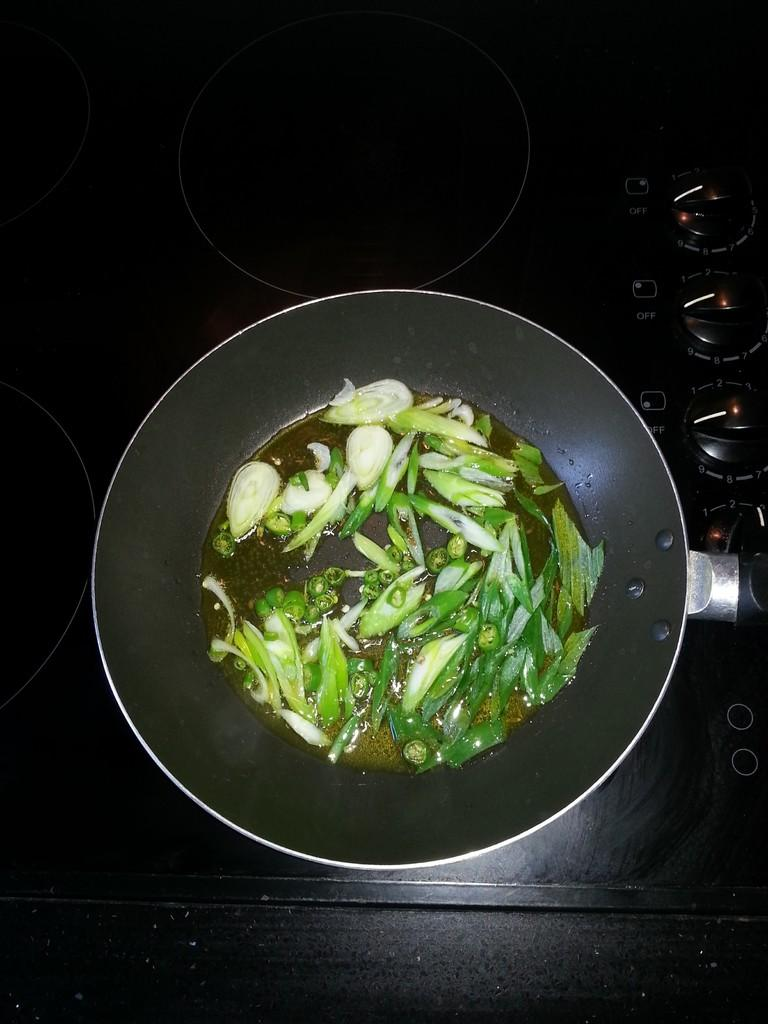What cooking appliance is present in the image? There is a stove in the image. What is placed on the stove? There is a pan on the stove. What ingredients are in the pan? The pan contains chilies and leafy vegetables. What type of stone is used to fuel the stove in the image? There is no stone used to fuel the stove in the image; it is likely powered by electricity or gas. 